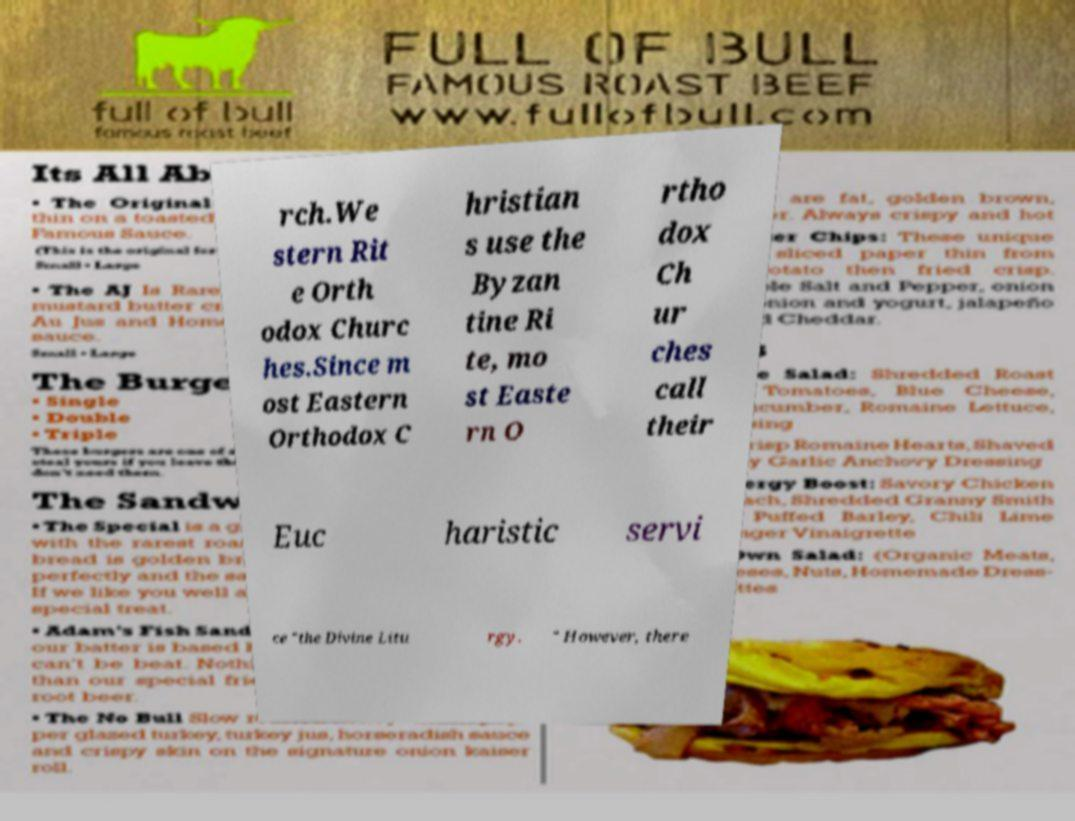I need the written content from this picture converted into text. Can you do that? rch.We stern Rit e Orth odox Churc hes.Since m ost Eastern Orthodox C hristian s use the Byzan tine Ri te, mo st Easte rn O rtho dox Ch ur ches call their Euc haristic servi ce "the Divine Litu rgy. " However, there 